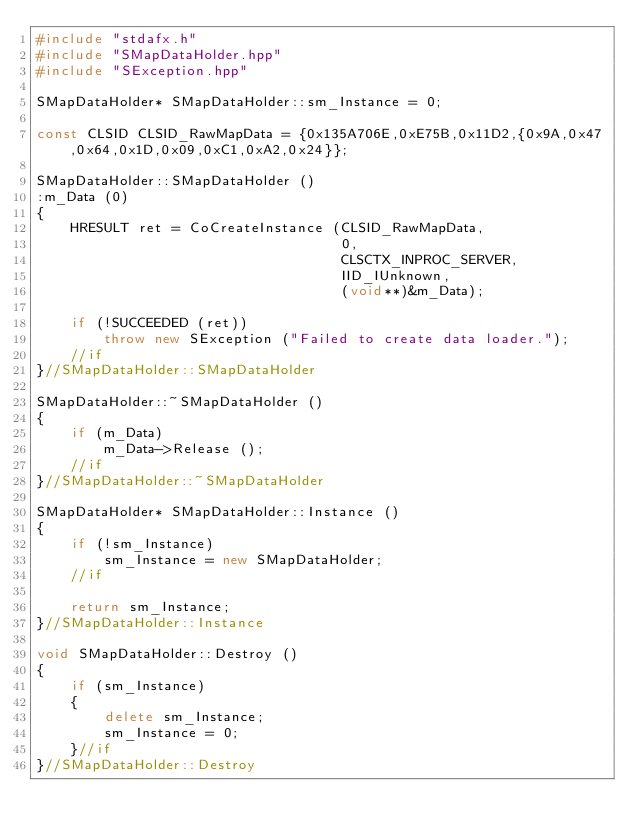<code> <loc_0><loc_0><loc_500><loc_500><_C++_>#include "stdafx.h"
#include "SMapDataHolder.hpp"
#include "SException.hpp"

SMapDataHolder*	SMapDataHolder::sm_Instance = 0;

const CLSID CLSID_RawMapData = {0x135A706E,0xE75B,0x11D2,{0x9A,0x47,0x64,0x1D,0x09,0xC1,0xA2,0x24}};

SMapDataHolder::SMapDataHolder ()
:m_Data (0)
{
	HRESULT ret = CoCreateInstance (CLSID_RawMapData,
									0,
									CLSCTX_INPROC_SERVER,
									IID_IUnknown,
									(void**)&m_Data); 

	if (!SUCCEEDED (ret))
		throw new SException ("Failed to create data loader.");
	//if
}//SMapDataHolder::SMapDataHolder

SMapDataHolder::~SMapDataHolder ()
{
	if (m_Data)
		m_Data->Release ();
	//if
}//SMapDataHolder::~SMapDataHolder

SMapDataHolder*	SMapDataHolder::Instance ()
{
	if (!sm_Instance)
		sm_Instance = new SMapDataHolder;
	//if

	return sm_Instance;
}//SMapDataHolder::Instance

void SMapDataHolder::Destroy ()
{
	if (sm_Instance)
	{
		delete sm_Instance;
		sm_Instance = 0;
	}//if
}//SMapDataHolder::Destroy




</code> 